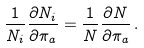<formula> <loc_0><loc_0><loc_500><loc_500>\frac { 1 } { N _ { i } } \frac { \partial N _ { i } } { \partial \pi _ { a } } = \frac { 1 } { N } \frac { \partial N } { \partial \pi _ { a } } \, .</formula> 